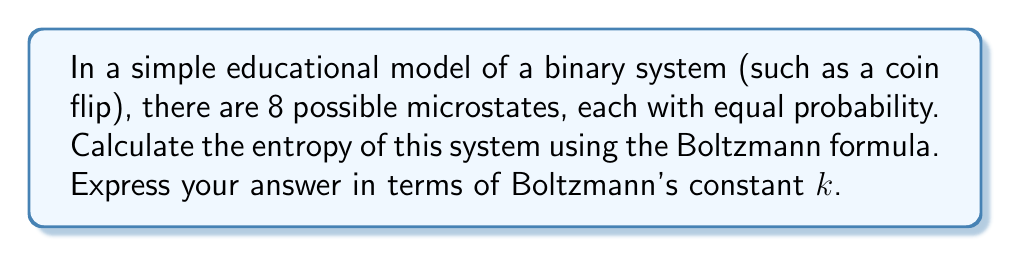Can you solve this math problem? Let's approach this step-by-step:

1) The Boltzmann formula for entropy is:

   $$S = k \ln W$$

   Where:
   $S$ is the entropy
   $k$ is Boltzmann's constant
   $W$ is the number of microstates

2) In this case, we're told that there are 8 possible microstates:

   $$W = 8$$

3) Substituting this into the Boltzmann formula:

   $$S = k \ln 8$$

4) We can simplify this further:

   $$S = k \ln 2^3 = 3k \ln 2$$

5) This is our final answer, expressed in terms of Boltzmann's constant $k$.

Note: In educational contexts, this model could be used to represent three independent coin flips, where each coin can be either heads or tails, resulting in $2^3 = 8$ possible outcomes.
Answer: $3k \ln 2$ 